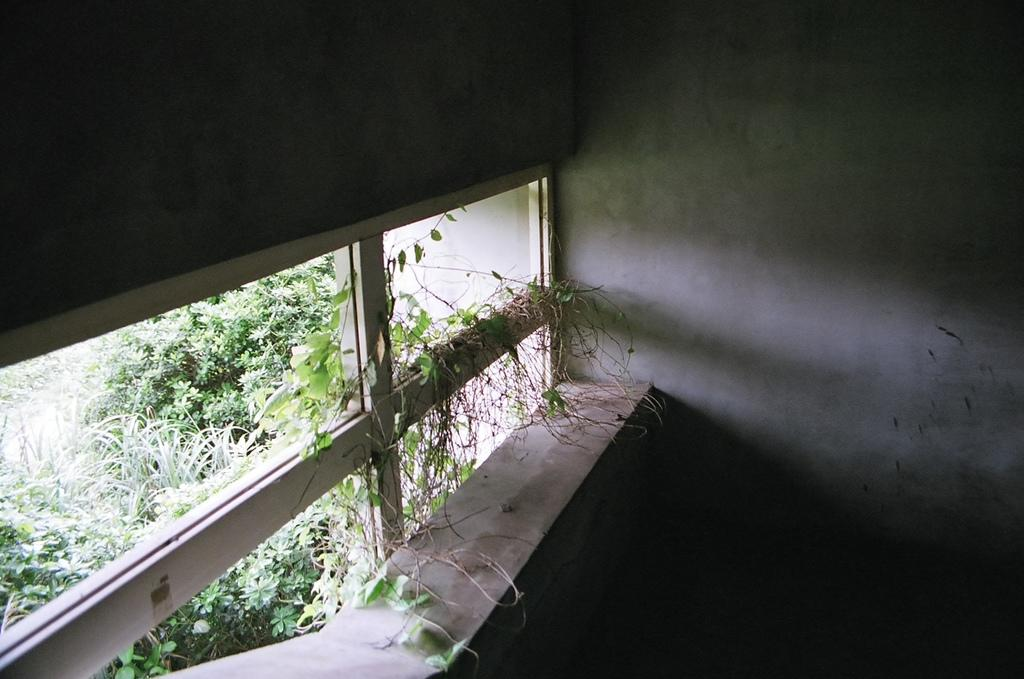What type of structure can be seen in the image? There is a wall in the image. What architectural feature is present in the wall? There are windows in the image. What type of vegetation is on the left side of the image? There are plants on the left side of the image. Can you see any socks hanging from the windows in the image? There are no socks present in the image. Is there an actor visible in the image? There is no actor visible in the image. 